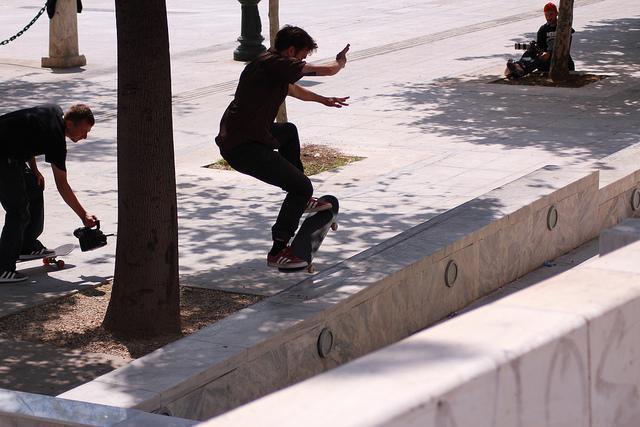What past time is the rightmost person involved in?
Select the accurate response from the four choices given to answer the question.
Options: Wakeboarding, skate boarding, photography, beer drinking. Photography. 